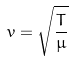Convert formula to latex. <formula><loc_0><loc_0><loc_500><loc_500>v = \sqrt { \frac { T } { \mu } }</formula> 